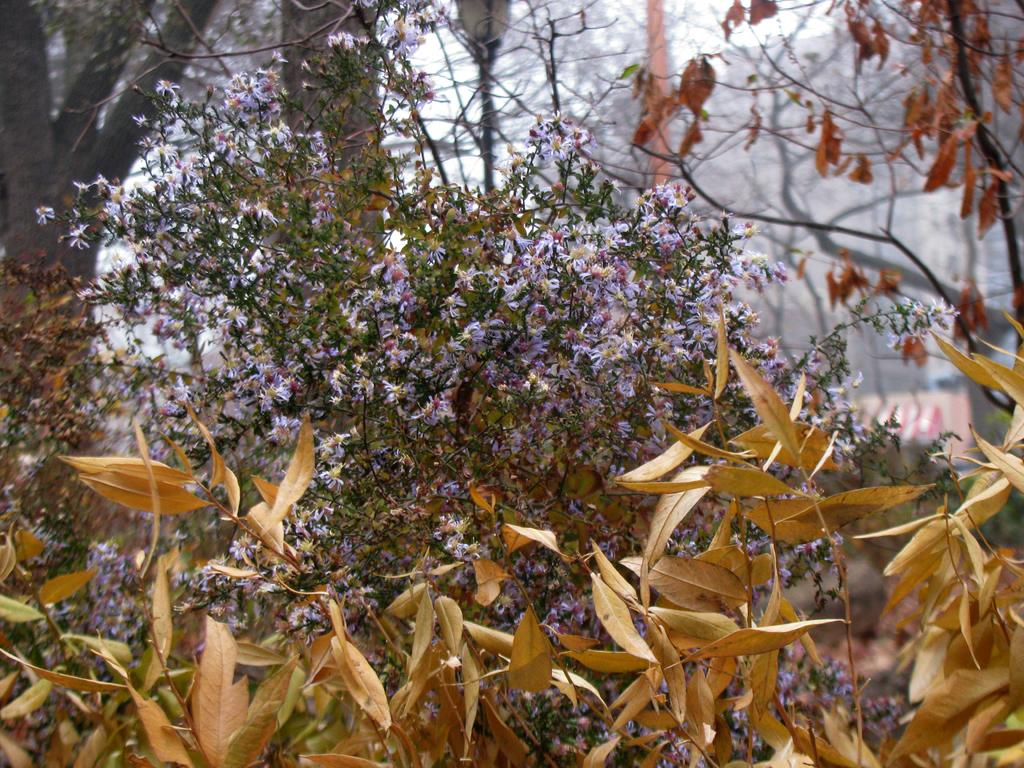What is at the bottom of the image? There are dry leaves at the bottom of the image. What type of plant is visible behind the dry leaves? There is a plant with leaves and flowers behind the dry leaves. What can be seen in the background of the image? Trees are visible in the background of the image. What type of collar is visible on the plant in the image? There is no collar present on the plant in the image. How does the temper of the plant change throughout the day in the image? The image does not provide information about the plant's temper, as it is not a living being. 